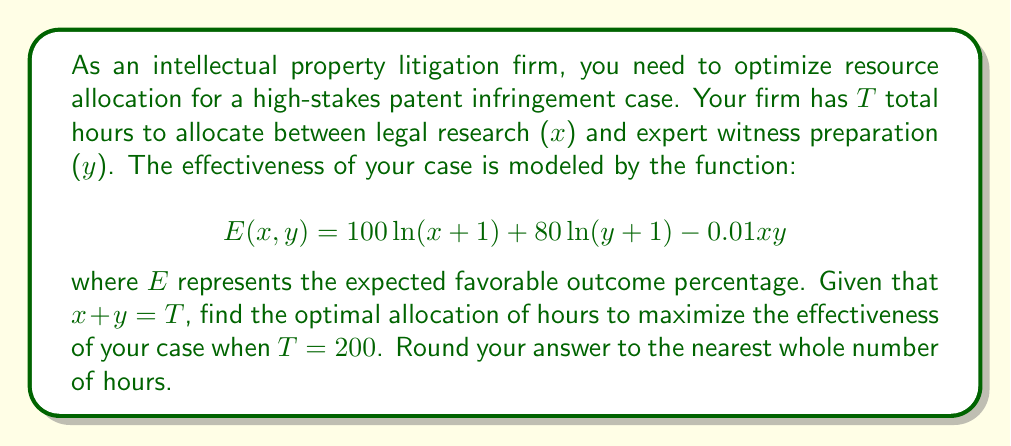Solve this math problem. To solve this optimization problem, we'll use the method of Lagrange multipliers:

1) First, we set up the Lagrangian function:
   $$L(x,y,\lambda) = 100\ln(x+1) + 80\ln(y+1) - 0.01xy + \lambda(T - x - y)$$

2) Now, we take partial derivatives and set them equal to zero:
   $$\frac{\partial L}{\partial x} = \frac{100}{x+1} - 0.01y - \lambda = 0$$
   $$\frac{\partial L}{\partial y} = \frac{80}{y+1} - 0.01x - \lambda = 0$$
   $$\frac{\partial L}{\partial \lambda} = T - x - y = 0$$

3) From the constraint equation, we know that $y = T - x = 200 - x$

4) Substituting this into the first two equations:
   $$\frac{100}{x+1} - 0.01(200-x) - \lambda = 0$$
   $$\frac{80}{(200-x)+1} - 0.01x - \lambda = 0$$

5) Equating these:
   $$\frac{100}{x+1} - 0.01(200-x) = \frac{80}{201-x} - 0.01x$$

6) Simplifying and solving numerically (as this equation is transcendental), we get:
   $$x \approx 111.8$$

7) Therefore, $y = 200 - 111.8 = 88.2$

8) Rounding to the nearest whole number:
   $x = 112$ and $y = 88$
Answer: 112 hours for legal research, 88 hours for expert witness preparation 